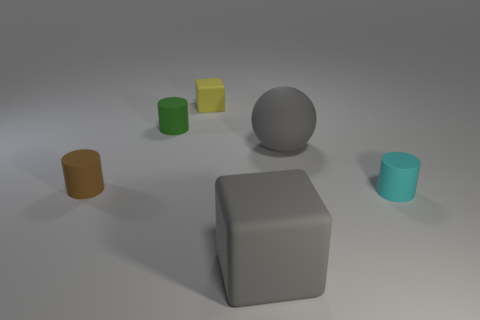Subtract all brown cylinders. How many cylinders are left? 2 Add 3 small yellow matte cubes. How many objects exist? 9 Subtract all balls. How many objects are left? 5 Add 3 small matte cubes. How many small matte cubes exist? 4 Subtract 0 red cylinders. How many objects are left? 6 Subtract all purple blocks. Subtract all green cylinders. How many objects are left? 5 Add 6 small green matte cylinders. How many small green matte cylinders are left? 7 